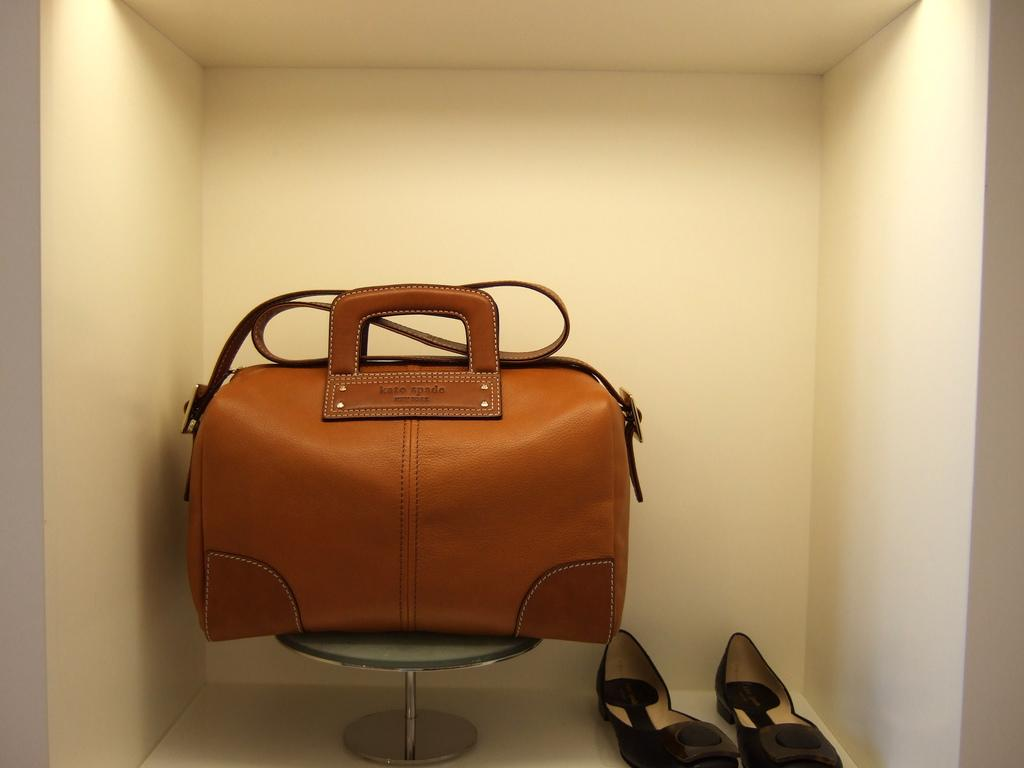What type of bag is visible in the image? There is a leather bag in the image. How is the leather bag positioned in the image? The leather bag is placed on a stand. What other item can be seen in the image? There is a women's shoe in the image. Where is the women's shoe located in the image? The women's shoe is on a wall-mounted shelf. What can be observed about the lighting in the image? Light rays are falling on the leather bag and women's shoe. How does the robin contribute to the garden in the image? There is no robin or garden present in the image; it only features a leather bag, a women's shoe, and related items. 